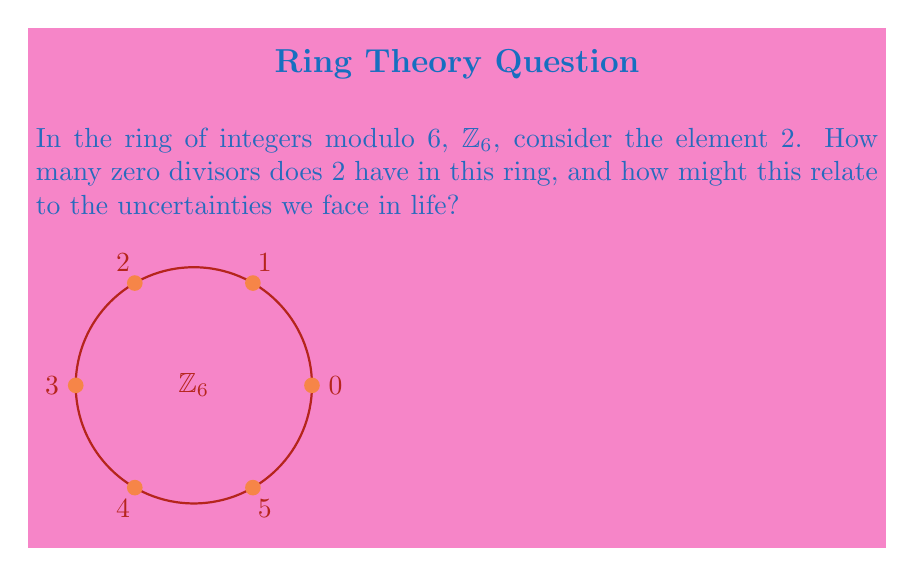Show me your answer to this math problem. Let's approach this step-by-step:

1) First, recall that in a ring, an element $a$ is a zero divisor if there exists a non-zero element $b$ such that $ab = 0$.

2) In $\mathbb{Z}_6$, we need to check which elements, when multiplied by 2, result in 0 (mod 6).

3) Let's multiply 2 by each element in $\mathbb{Z}_6$:
   
   $2 \cdot 0 \equiv 0 \pmod{6}$
   $2 \cdot 1 \equiv 2 \pmod{6}$
   $2 \cdot 2 \equiv 4 \pmod{6}$
   $2 \cdot 3 \equiv 0 \pmod{6}$
   $2 \cdot 4 \equiv 2 \pmod{6}$
   $2 \cdot 5 \equiv 4 \pmod{6}$

4) We see that $2 \cdot 3 \equiv 0 \pmod{6}$, and 3 is non-zero in $\mathbb{Z}_6$. Therefore, 3 is a zero divisor of 2.

5) No other non-zero element in $\mathbb{Z}_6$ gives 0 when multiplied by 2.

6) Thus, 2 has exactly one zero divisor in $\mathbb{Z}_6$.

Relating this to life's uncertainties:
Just as 2 has an unexpected partner (3) that leads to zero in this mathematical structure, life often presents us with unexpected factors that can nullify our efforts or change our direction. This mathematical concept reminds us that in life, there may be unforeseen elements that interact with our plans in ways we didn't anticipate, leading to unexpected outcomes. It's a reminder to approach life with openness and adaptability, understanding that our path may intersect with factors we didn't initially consider.
Answer: 2 has 1 zero divisor in $\mathbb{Z}_6$. 